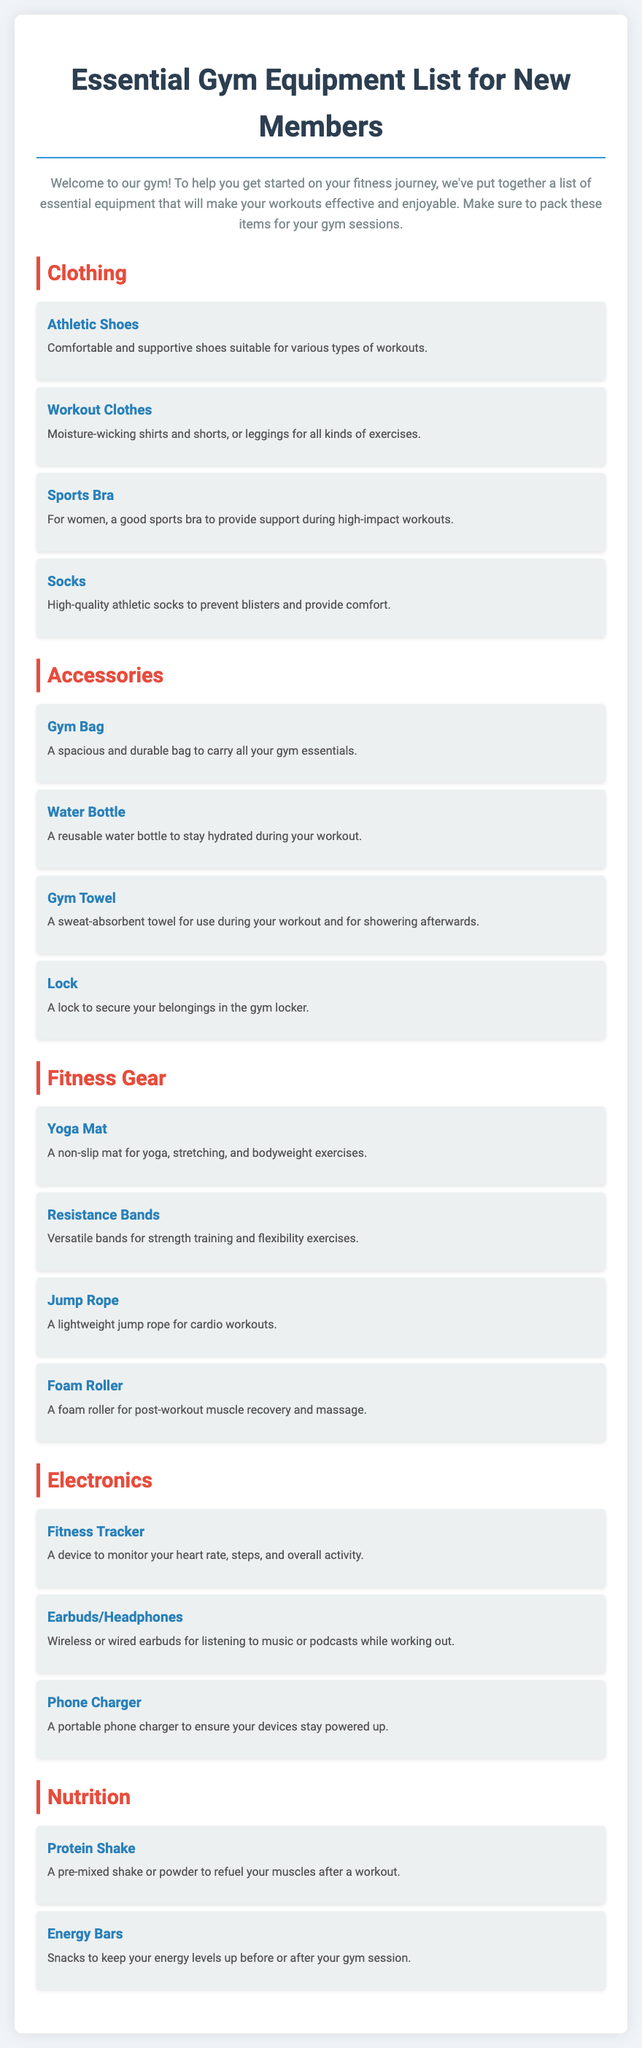What is the title of the document? The title is the main heading that introduces the content of the document.
Answer: Essential Gym Equipment List for New Members How many categories of items are listed? The document contains distinct sections for displaying different types of essential items.
Answer: Five What item is recommended for hydration? This is a specific item mentioned in the accessories category that helps in staying hydrated during workouts.
Answer: Water Bottle Which type of clothing is suggested for high-impact workouts? This question looks for a specific clothing item tailored for women that provides support.
Answer: Sports Bra What type of electronic device is suggested for monitoring activity? The document provides a specific item under the electronics category designed to track fitness metrics.
Answer: Fitness Tracker What is one purpose of using a Foam Roller? This question requires reasoning about the function of an item listed in the fitness gear category.
Answer: Muscle recovery What is the purpose of a gym bag? This question captures the utility of a bag mentioned among the accessories, focusing on its intended use.
Answer: Carry essentials How many items are listed under the Nutrition category? The question seeks the count of items contributed within the nutrition section of the document.
Answer: Two 